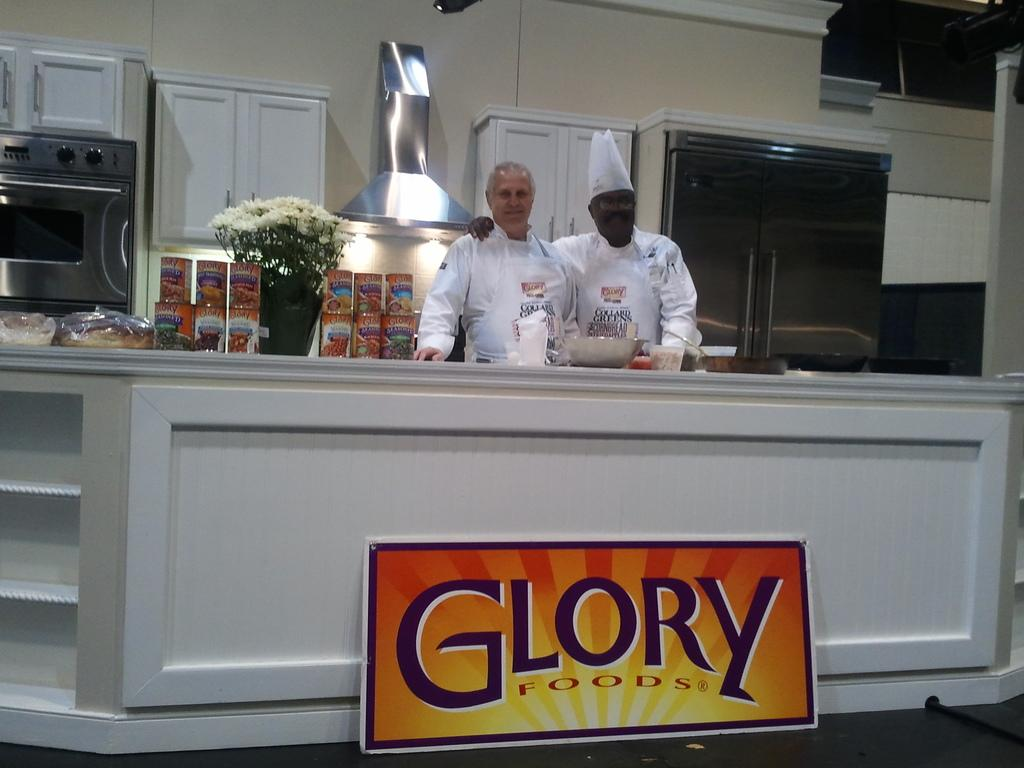<image>
Provide a brief description of the given image. Two chefs proudly stand behind a counter belwo which is a sign for Glory Foods 